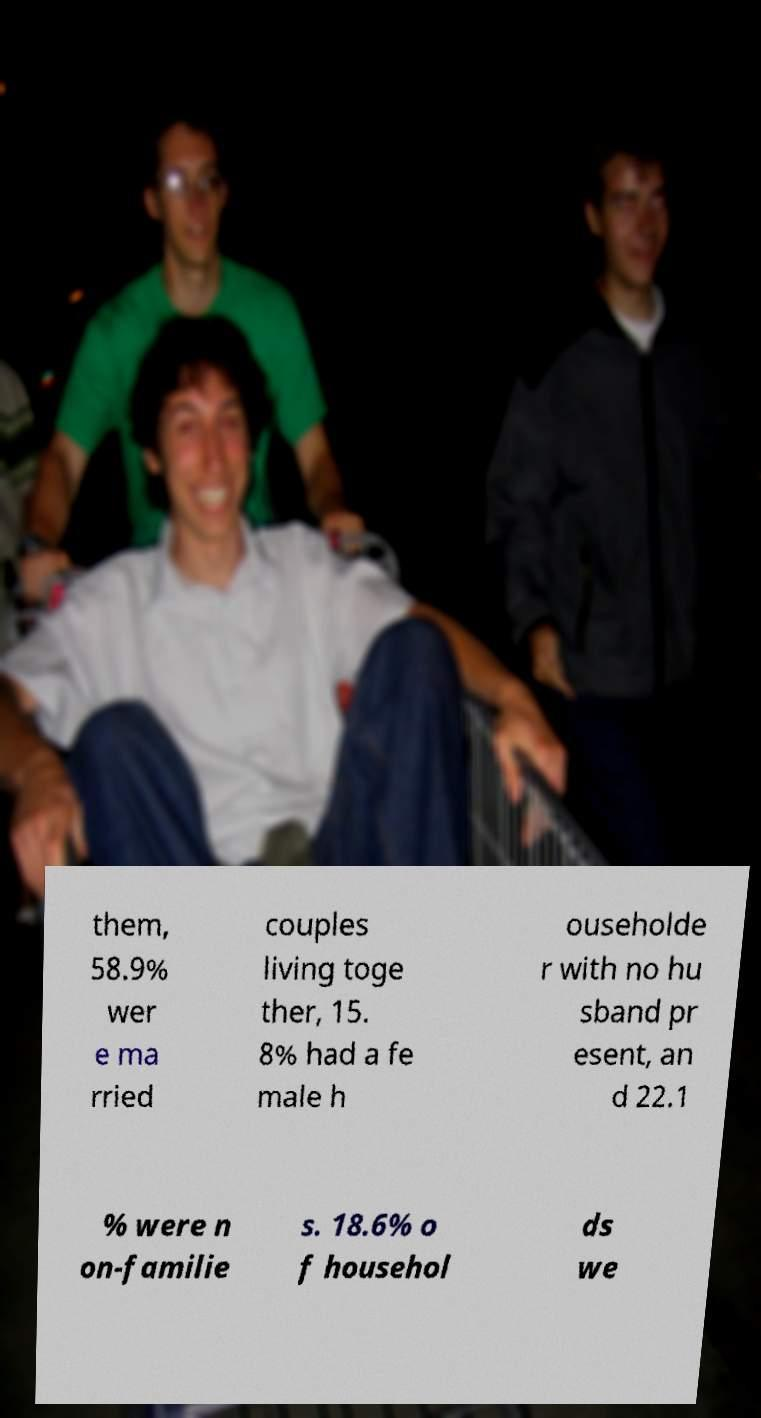Can you read and provide the text displayed in the image?This photo seems to have some interesting text. Can you extract and type it out for me? them, 58.9% wer e ma rried couples living toge ther, 15. 8% had a fe male h ouseholde r with no hu sband pr esent, an d 22.1 % were n on-familie s. 18.6% o f househol ds we 